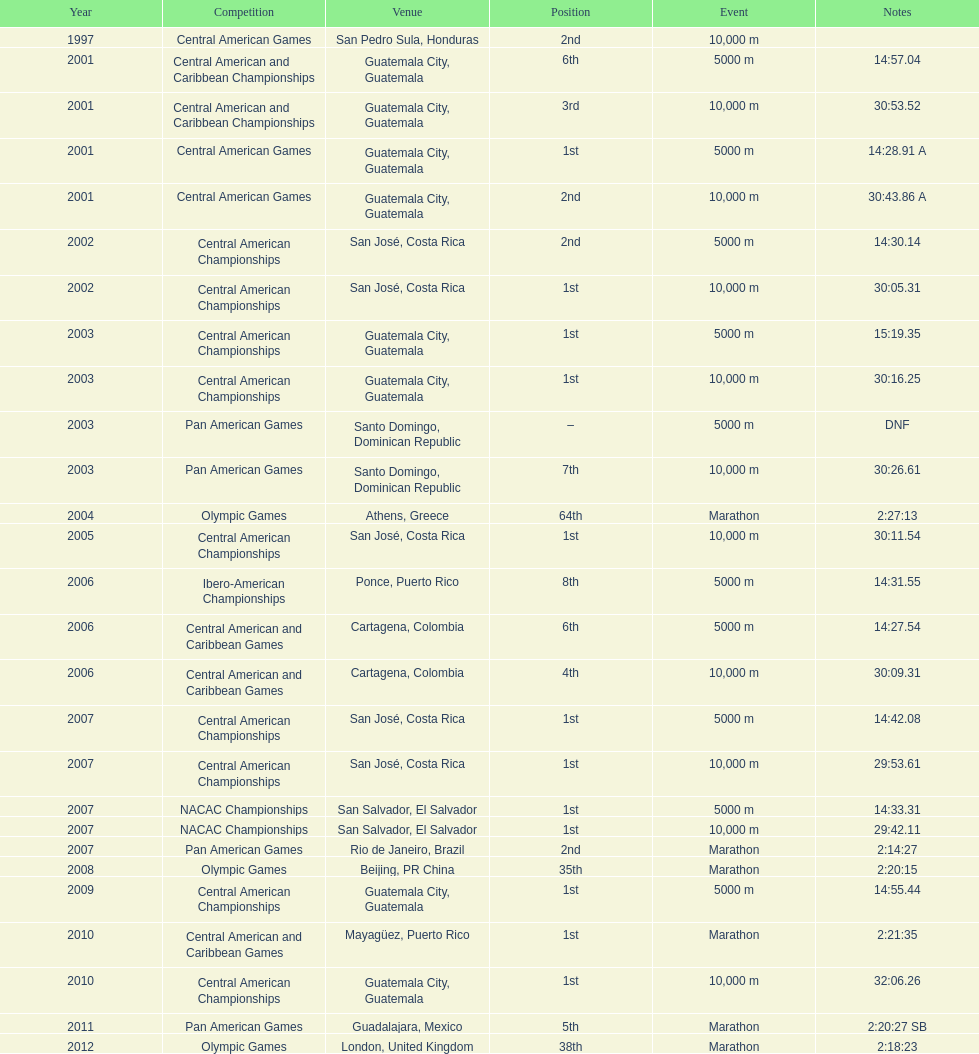Which race is cited more often between the 10,000m and the 5000m? 10,000 m. 